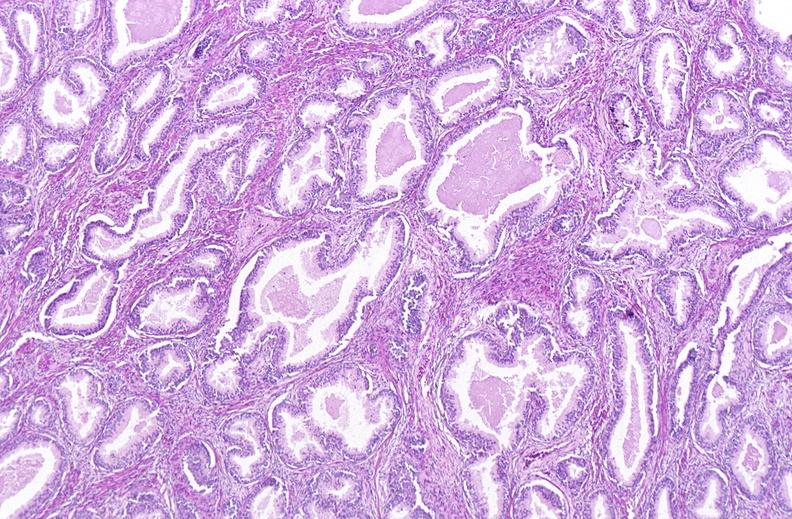what does this image show?
Answer the question using a single word or phrase. Prostate 